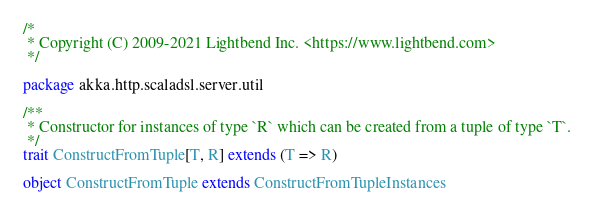Convert code to text. <code><loc_0><loc_0><loc_500><loc_500><_Scala_>/*
 * Copyright (C) 2009-2021 Lightbend Inc. <https://www.lightbend.com>
 */

package akka.http.scaladsl.server.util

/**
 * Constructor for instances of type `R` which can be created from a tuple of type `T`.
 */
trait ConstructFromTuple[T, R] extends (T => R)

object ConstructFromTuple extends ConstructFromTupleInstances
</code> 